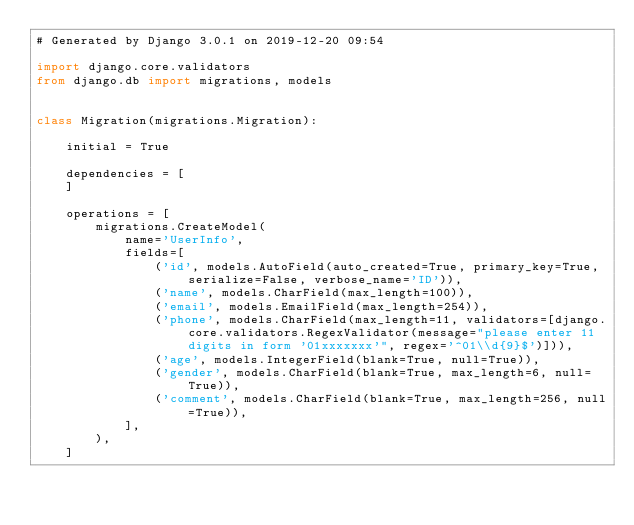Convert code to text. <code><loc_0><loc_0><loc_500><loc_500><_Python_># Generated by Django 3.0.1 on 2019-12-20 09:54

import django.core.validators
from django.db import migrations, models


class Migration(migrations.Migration):

    initial = True

    dependencies = [
    ]

    operations = [
        migrations.CreateModel(
            name='UserInfo',
            fields=[
                ('id', models.AutoField(auto_created=True, primary_key=True, serialize=False, verbose_name='ID')),
                ('name', models.CharField(max_length=100)),
                ('email', models.EmailField(max_length=254)),
                ('phone', models.CharField(max_length=11, validators=[django.core.validators.RegexValidator(message="please enter 11 digits in form '01xxxxxxx'", regex='^01\\d{9}$')])),
                ('age', models.IntegerField(blank=True, null=True)),
                ('gender', models.CharField(blank=True, max_length=6, null=True)),
                ('comment', models.CharField(blank=True, max_length=256, null=True)),
            ],
        ),
    ]
</code> 